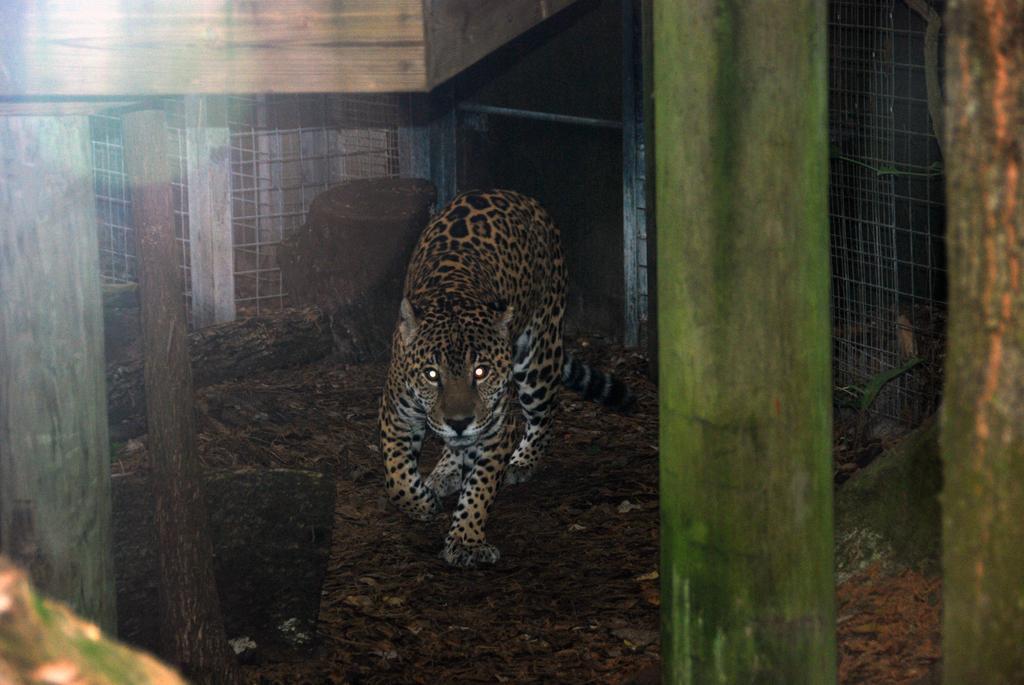In one or two sentences, can you explain what this image depicts? In this image we can see an animal. And we can see the wooden logs. And we can see the metal fence. 